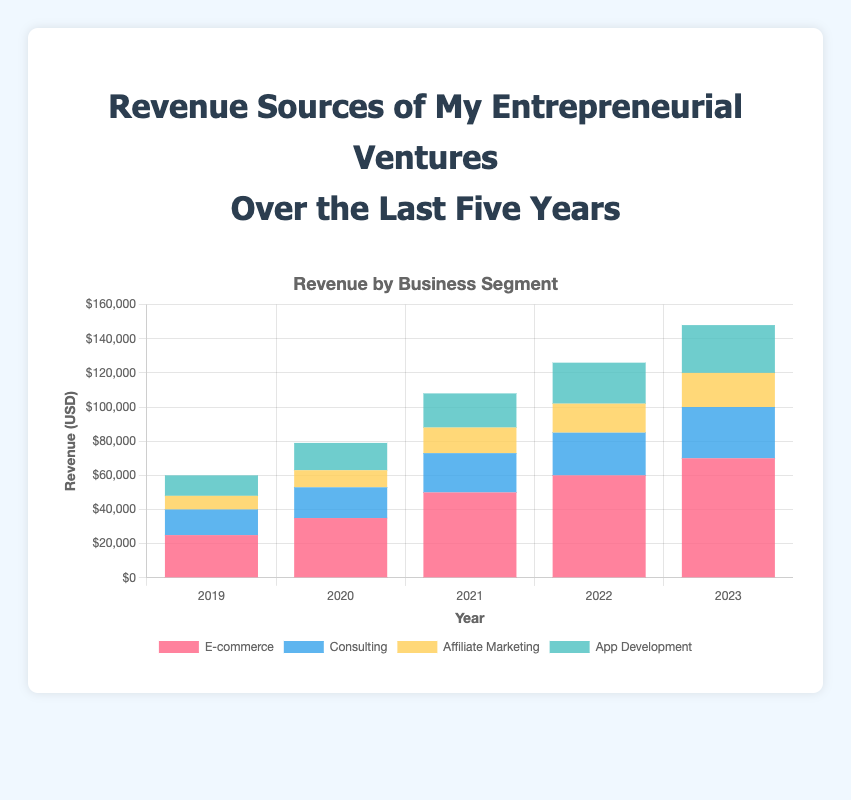What is the total revenue for E-commerce in 2023? The chart shows a stacked bar for 2023 broken down by segments. Look for the E-commerce segment (usually in a distinct color) and read its value.
Answer: 70000 Which business segment had the highest revenue in 2020? Examine the segments for the year 2020 and compare the heights of the different colored bars. Identify the one that is the tallest.
Answer: E-commerce How did the revenue from Consulting change from 2019 to 2023? Look for the Consulting segment's revenue for each year from 2019 to 2023. Notice the trend, whether it increased, decreased, or remained constant. Calculate the difference from the start to the end year.
Answer: Increased by 15000 What is the revenue difference between E-commerce and Affiliate Marketing in 2021? Identify the values for E-commerce and Affiliate Marketing segments in 2021. Subtract the smaller value from the larger value to calculate the difference.
Answer: 35000 In which year did App Development see the maximum increase compared to the previous year? Calculate the year-over-year growth for App Development by subtracting the previous year's revenue from the current year's for each year. Compare the growths to identify the largest one.
Answer: 2023 Compare the revenue contributions of Affiliate Marketing and Consulting in 2022. Which one is higher, and by how much? Identify the revenues for Affiliate Marketing and Consulting in 2022. Subtract the smaller value from the larger value to find the difference and determine which is higher.
Answer: Consulting by 8000 If you sum up all revenues from all segments for 2020, what is the total revenue for that year? Add the revenues from E-commerce, Consulting, Affiliate Marketing, and App Development segments for 2020.
Answer: 79000 What percentage of the total revenue in 2021 came from E-commerce? First, calculate the total revenue of all segments in 2021. Then, divide the E-commerce revenue by this total and multiply by 100 to get the percentage.
Answer: ~52% How does the revenue trend for Affiliate Marketing from 2019 to 2023 visualize? Observe the heights of the bars representing Affiliate Marketing across the years 2019 to 2023. Describe whether it is increasing, decreasing, or showing mixed trends.
Answer: Increasing In which segment and year was the smallest revenue recorded? Compare the values across all segments and years shown. Identify the smallest value and note the corresponding segment and year.
Answer: Affiliate Marketing in 2019 